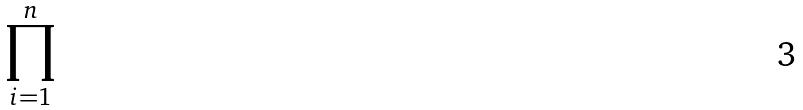<formula> <loc_0><loc_0><loc_500><loc_500>\prod _ { i = 1 } ^ { n }</formula> 